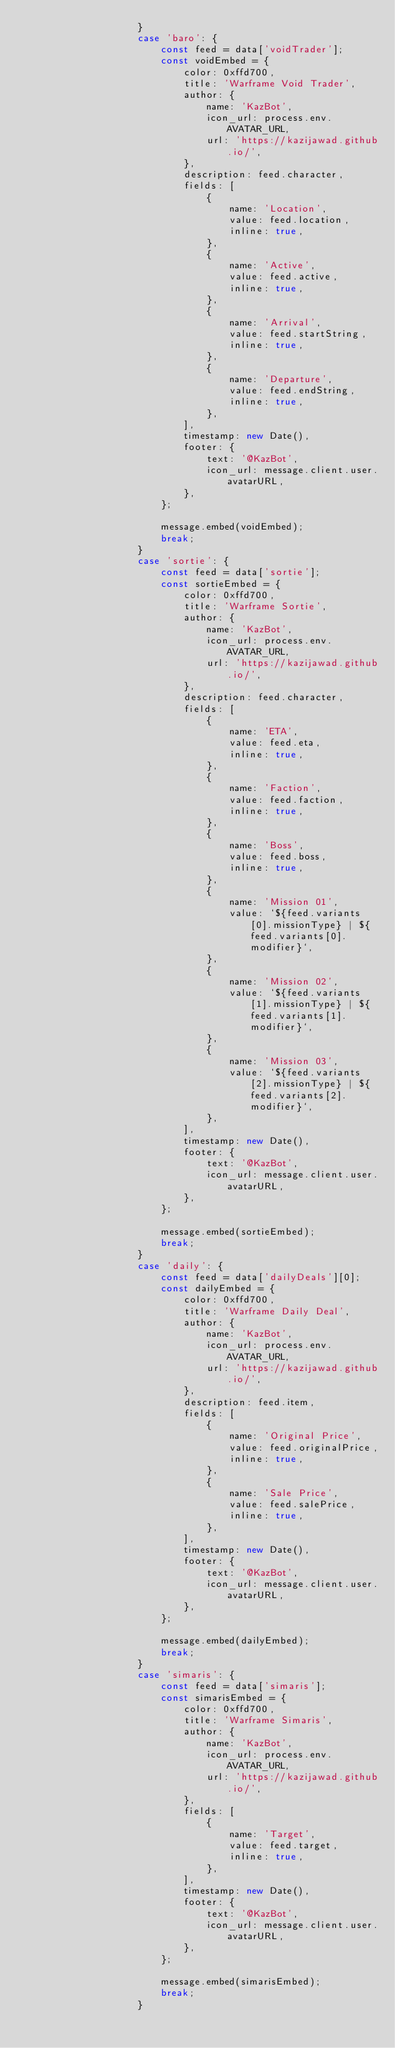Convert code to text. <code><loc_0><loc_0><loc_500><loc_500><_JavaScript_>					}
					case 'baro': {
						const feed = data['voidTrader'];
						const voidEmbed = {
							color: 0xffd700,
							title: 'Warframe Void Trader',
							author: {
								name: 'KazBot',
								icon_url: process.env.AVATAR_URL,
								url: 'https://kazijawad.github.io/',
							},
							description: feed.character,
							fields: [
								{
									name: 'Location',
									value: feed.location,
									inline: true,
								},
								{
									name: 'Active',
									value: feed.active,
									inline: true,
								},
								{
									name: 'Arrival',
									value: feed.startString,
									inline: true,
								},
								{
									name: 'Departure',
									value: feed.endString,
									inline: true,
								},
							],
							timestamp: new Date(),
							footer: {
								text: '@KazBot',
								icon_url: message.client.user.avatarURL,
							},
						};

						message.embed(voidEmbed);
						break;
					}
					case 'sortie': {
						const feed = data['sortie'];
						const sortieEmbed = {
							color: 0xffd700,
							title: 'Warframe Sortie',
							author: {
								name: 'KazBot',
								icon_url: process.env.AVATAR_URL,
								url: 'https://kazijawad.github.io/',
							},
							description: feed.character,
							fields: [
								{
									name: 'ETA',
									value: feed.eta,
									inline: true,
								},
								{
									name: 'Faction',
									value: feed.faction,
									inline: true,
								},
								{
									name: 'Boss',
									value: feed.boss,
									inline: true,
								},
								{
									name: 'Mission 01',
									value: `${feed.variants[0].missionType} | ${feed.variants[0].modifier}`,
								},
								{
									name: 'Mission 02',
									value: `${feed.variants[1].missionType} | ${feed.variants[1].modifier}`,
								},
								{
									name: 'Mission 03',
									value: `${feed.variants[2].missionType} | ${feed.variants[2].modifier}`,
								},
							],
							timestamp: new Date(),
							footer: {
								text: '@KazBot',
								icon_url: message.client.user.avatarURL,
							},
						};

						message.embed(sortieEmbed);
						break;
					}
					case 'daily': {
						const feed = data['dailyDeals'][0];
						const dailyEmbed = {
							color: 0xffd700,
							title: 'Warframe Daily Deal',
							author: {
								name: 'KazBot',
								icon_url: process.env.AVATAR_URL,
								url: 'https://kazijawad.github.io/',
							},
							description: feed.item,
							fields: [
								{
									name: 'Original Price',
									value: feed.originalPrice,
									inline: true,
								},
								{
									name: 'Sale Price',
									value: feed.salePrice,
									inline: true,
								},
							],
							timestamp: new Date(),
							footer: {
								text: '@KazBot',
								icon_url: message.client.user.avatarURL,
							},
						};

						message.embed(dailyEmbed);
						break;
					}
					case 'simaris': {
						const feed = data['simaris'];
						const simarisEmbed = {
							color: 0xffd700,
							title: 'Warframe Simaris',
							author: {
								name: 'KazBot',
								icon_url: process.env.AVATAR_URL,
								url: 'https://kazijawad.github.io/',
							},
							fields: [
								{
									name: 'Target',
									value: feed.target,
									inline: true,
								},
							],
							timestamp: new Date(),
							footer: {
								text: '@KazBot',
								icon_url: message.client.user.avatarURL,
							},
						};

						message.embed(simarisEmbed);
						break;
					}</code> 